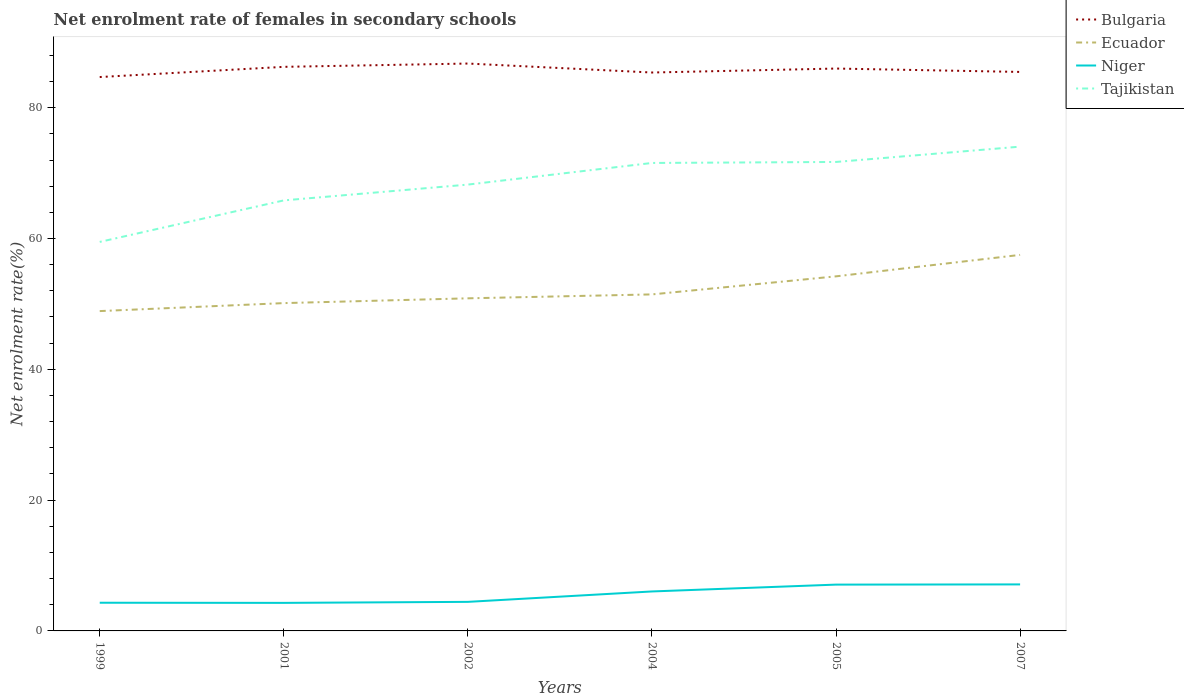How many different coloured lines are there?
Your answer should be compact. 4. Does the line corresponding to Bulgaria intersect with the line corresponding to Ecuador?
Ensure brevity in your answer.  No. Across all years, what is the maximum net enrolment rate of females in secondary schools in Tajikistan?
Provide a short and direct response. 59.48. In which year was the net enrolment rate of females in secondary schools in Bulgaria maximum?
Your answer should be very brief. 1999. What is the total net enrolment rate of females in secondary schools in Tajikistan in the graph?
Your answer should be very brief. -8.22. What is the difference between the highest and the second highest net enrolment rate of females in secondary schools in Tajikistan?
Your answer should be very brief. 14.57. What is the difference between the highest and the lowest net enrolment rate of females in secondary schools in Bulgaria?
Your response must be concise. 3. How many lines are there?
Provide a succinct answer. 4. What is the difference between two consecutive major ticks on the Y-axis?
Your answer should be very brief. 20. Are the values on the major ticks of Y-axis written in scientific E-notation?
Your answer should be very brief. No. How many legend labels are there?
Offer a very short reply. 4. How are the legend labels stacked?
Keep it short and to the point. Vertical. What is the title of the graph?
Your answer should be very brief. Net enrolment rate of females in secondary schools. Does "Sub-Saharan Africa (all income levels)" appear as one of the legend labels in the graph?
Provide a short and direct response. No. What is the label or title of the Y-axis?
Provide a short and direct response. Net enrolment rate(%). What is the Net enrolment rate(%) of Bulgaria in 1999?
Keep it short and to the point. 84.69. What is the Net enrolment rate(%) in Ecuador in 1999?
Give a very brief answer. 48.9. What is the Net enrolment rate(%) in Niger in 1999?
Provide a succinct answer. 4.31. What is the Net enrolment rate(%) in Tajikistan in 1999?
Provide a succinct answer. 59.48. What is the Net enrolment rate(%) in Bulgaria in 2001?
Offer a terse response. 86.25. What is the Net enrolment rate(%) of Ecuador in 2001?
Keep it short and to the point. 50.12. What is the Net enrolment rate(%) of Niger in 2001?
Offer a terse response. 4.29. What is the Net enrolment rate(%) in Tajikistan in 2001?
Provide a succinct answer. 65.83. What is the Net enrolment rate(%) in Bulgaria in 2002?
Your answer should be very brief. 86.75. What is the Net enrolment rate(%) of Ecuador in 2002?
Provide a succinct answer. 50.85. What is the Net enrolment rate(%) in Niger in 2002?
Offer a very short reply. 4.44. What is the Net enrolment rate(%) in Tajikistan in 2002?
Keep it short and to the point. 68.24. What is the Net enrolment rate(%) of Bulgaria in 2004?
Offer a terse response. 85.38. What is the Net enrolment rate(%) of Ecuador in 2004?
Offer a terse response. 51.45. What is the Net enrolment rate(%) of Niger in 2004?
Ensure brevity in your answer.  6.04. What is the Net enrolment rate(%) in Tajikistan in 2004?
Provide a succinct answer. 71.55. What is the Net enrolment rate(%) in Bulgaria in 2005?
Offer a terse response. 85.99. What is the Net enrolment rate(%) of Ecuador in 2005?
Your answer should be very brief. 54.21. What is the Net enrolment rate(%) in Niger in 2005?
Provide a short and direct response. 7.08. What is the Net enrolment rate(%) in Tajikistan in 2005?
Offer a terse response. 71.7. What is the Net enrolment rate(%) of Bulgaria in 2007?
Provide a succinct answer. 85.47. What is the Net enrolment rate(%) of Ecuador in 2007?
Keep it short and to the point. 57.49. What is the Net enrolment rate(%) of Niger in 2007?
Keep it short and to the point. 7.11. What is the Net enrolment rate(%) of Tajikistan in 2007?
Your answer should be compact. 74.05. Across all years, what is the maximum Net enrolment rate(%) of Bulgaria?
Make the answer very short. 86.75. Across all years, what is the maximum Net enrolment rate(%) in Ecuador?
Give a very brief answer. 57.49. Across all years, what is the maximum Net enrolment rate(%) of Niger?
Ensure brevity in your answer.  7.11. Across all years, what is the maximum Net enrolment rate(%) of Tajikistan?
Your answer should be very brief. 74.05. Across all years, what is the minimum Net enrolment rate(%) of Bulgaria?
Make the answer very short. 84.69. Across all years, what is the minimum Net enrolment rate(%) of Ecuador?
Your answer should be compact. 48.9. Across all years, what is the minimum Net enrolment rate(%) of Niger?
Ensure brevity in your answer.  4.29. Across all years, what is the minimum Net enrolment rate(%) of Tajikistan?
Provide a succinct answer. 59.48. What is the total Net enrolment rate(%) in Bulgaria in the graph?
Ensure brevity in your answer.  514.52. What is the total Net enrolment rate(%) of Ecuador in the graph?
Give a very brief answer. 313.04. What is the total Net enrolment rate(%) in Niger in the graph?
Offer a very short reply. 33.27. What is the total Net enrolment rate(%) of Tajikistan in the graph?
Offer a very short reply. 410.85. What is the difference between the Net enrolment rate(%) of Bulgaria in 1999 and that in 2001?
Ensure brevity in your answer.  -1.56. What is the difference between the Net enrolment rate(%) in Ecuador in 1999 and that in 2001?
Keep it short and to the point. -1.22. What is the difference between the Net enrolment rate(%) of Niger in 1999 and that in 2001?
Your response must be concise. 0.02. What is the difference between the Net enrolment rate(%) in Tajikistan in 1999 and that in 2001?
Your response must be concise. -6.35. What is the difference between the Net enrolment rate(%) in Bulgaria in 1999 and that in 2002?
Provide a succinct answer. -2.06. What is the difference between the Net enrolment rate(%) in Ecuador in 1999 and that in 2002?
Your answer should be very brief. -1.95. What is the difference between the Net enrolment rate(%) of Niger in 1999 and that in 2002?
Your response must be concise. -0.13. What is the difference between the Net enrolment rate(%) of Tajikistan in 1999 and that in 2002?
Offer a terse response. -8.77. What is the difference between the Net enrolment rate(%) of Bulgaria in 1999 and that in 2004?
Your answer should be compact. -0.69. What is the difference between the Net enrolment rate(%) of Ecuador in 1999 and that in 2004?
Your response must be concise. -2.55. What is the difference between the Net enrolment rate(%) of Niger in 1999 and that in 2004?
Offer a terse response. -1.73. What is the difference between the Net enrolment rate(%) of Tajikistan in 1999 and that in 2004?
Give a very brief answer. -12.07. What is the difference between the Net enrolment rate(%) of Bulgaria in 1999 and that in 2005?
Ensure brevity in your answer.  -1.3. What is the difference between the Net enrolment rate(%) in Ecuador in 1999 and that in 2005?
Your answer should be compact. -5.31. What is the difference between the Net enrolment rate(%) in Niger in 1999 and that in 2005?
Give a very brief answer. -2.77. What is the difference between the Net enrolment rate(%) of Tajikistan in 1999 and that in 2005?
Make the answer very short. -12.23. What is the difference between the Net enrolment rate(%) of Bulgaria in 1999 and that in 2007?
Provide a succinct answer. -0.78. What is the difference between the Net enrolment rate(%) in Ecuador in 1999 and that in 2007?
Provide a succinct answer. -8.59. What is the difference between the Net enrolment rate(%) of Niger in 1999 and that in 2007?
Make the answer very short. -2.8. What is the difference between the Net enrolment rate(%) of Tajikistan in 1999 and that in 2007?
Provide a succinct answer. -14.57. What is the difference between the Net enrolment rate(%) of Bulgaria in 2001 and that in 2002?
Your answer should be very brief. -0.51. What is the difference between the Net enrolment rate(%) of Ecuador in 2001 and that in 2002?
Keep it short and to the point. -0.73. What is the difference between the Net enrolment rate(%) of Niger in 2001 and that in 2002?
Offer a terse response. -0.16. What is the difference between the Net enrolment rate(%) in Tajikistan in 2001 and that in 2002?
Offer a terse response. -2.42. What is the difference between the Net enrolment rate(%) in Bulgaria in 2001 and that in 2004?
Offer a very short reply. 0.87. What is the difference between the Net enrolment rate(%) in Ecuador in 2001 and that in 2004?
Offer a very short reply. -1.33. What is the difference between the Net enrolment rate(%) in Niger in 2001 and that in 2004?
Give a very brief answer. -1.75. What is the difference between the Net enrolment rate(%) of Tajikistan in 2001 and that in 2004?
Make the answer very short. -5.72. What is the difference between the Net enrolment rate(%) in Bulgaria in 2001 and that in 2005?
Keep it short and to the point. 0.26. What is the difference between the Net enrolment rate(%) of Ecuador in 2001 and that in 2005?
Offer a terse response. -4.09. What is the difference between the Net enrolment rate(%) in Niger in 2001 and that in 2005?
Offer a very short reply. -2.79. What is the difference between the Net enrolment rate(%) of Tajikistan in 2001 and that in 2005?
Make the answer very short. -5.88. What is the difference between the Net enrolment rate(%) in Bulgaria in 2001 and that in 2007?
Offer a terse response. 0.78. What is the difference between the Net enrolment rate(%) in Ecuador in 2001 and that in 2007?
Provide a short and direct response. -7.37. What is the difference between the Net enrolment rate(%) of Niger in 2001 and that in 2007?
Keep it short and to the point. -2.82. What is the difference between the Net enrolment rate(%) in Tajikistan in 2001 and that in 2007?
Offer a very short reply. -8.22. What is the difference between the Net enrolment rate(%) of Bulgaria in 2002 and that in 2004?
Ensure brevity in your answer.  1.37. What is the difference between the Net enrolment rate(%) in Ecuador in 2002 and that in 2004?
Your response must be concise. -0.6. What is the difference between the Net enrolment rate(%) in Niger in 2002 and that in 2004?
Provide a short and direct response. -1.59. What is the difference between the Net enrolment rate(%) of Tajikistan in 2002 and that in 2004?
Offer a terse response. -3.31. What is the difference between the Net enrolment rate(%) of Bulgaria in 2002 and that in 2005?
Your response must be concise. 0.77. What is the difference between the Net enrolment rate(%) in Ecuador in 2002 and that in 2005?
Ensure brevity in your answer.  -3.36. What is the difference between the Net enrolment rate(%) in Niger in 2002 and that in 2005?
Provide a succinct answer. -2.64. What is the difference between the Net enrolment rate(%) in Tajikistan in 2002 and that in 2005?
Ensure brevity in your answer.  -3.46. What is the difference between the Net enrolment rate(%) of Bulgaria in 2002 and that in 2007?
Ensure brevity in your answer.  1.28. What is the difference between the Net enrolment rate(%) in Ecuador in 2002 and that in 2007?
Give a very brief answer. -6.64. What is the difference between the Net enrolment rate(%) in Niger in 2002 and that in 2007?
Keep it short and to the point. -2.67. What is the difference between the Net enrolment rate(%) of Tajikistan in 2002 and that in 2007?
Provide a succinct answer. -5.8. What is the difference between the Net enrolment rate(%) in Bulgaria in 2004 and that in 2005?
Provide a succinct answer. -0.61. What is the difference between the Net enrolment rate(%) in Ecuador in 2004 and that in 2005?
Your answer should be very brief. -2.76. What is the difference between the Net enrolment rate(%) in Niger in 2004 and that in 2005?
Make the answer very short. -1.05. What is the difference between the Net enrolment rate(%) of Tajikistan in 2004 and that in 2005?
Your answer should be compact. -0.15. What is the difference between the Net enrolment rate(%) of Bulgaria in 2004 and that in 2007?
Offer a terse response. -0.09. What is the difference between the Net enrolment rate(%) of Ecuador in 2004 and that in 2007?
Your answer should be very brief. -6.04. What is the difference between the Net enrolment rate(%) of Niger in 2004 and that in 2007?
Give a very brief answer. -1.08. What is the difference between the Net enrolment rate(%) of Tajikistan in 2004 and that in 2007?
Your answer should be very brief. -2.5. What is the difference between the Net enrolment rate(%) of Bulgaria in 2005 and that in 2007?
Your answer should be very brief. 0.52. What is the difference between the Net enrolment rate(%) in Ecuador in 2005 and that in 2007?
Provide a short and direct response. -3.28. What is the difference between the Net enrolment rate(%) of Niger in 2005 and that in 2007?
Provide a short and direct response. -0.03. What is the difference between the Net enrolment rate(%) in Tajikistan in 2005 and that in 2007?
Keep it short and to the point. -2.34. What is the difference between the Net enrolment rate(%) in Bulgaria in 1999 and the Net enrolment rate(%) in Ecuador in 2001?
Offer a terse response. 34.56. What is the difference between the Net enrolment rate(%) of Bulgaria in 1999 and the Net enrolment rate(%) of Niger in 2001?
Give a very brief answer. 80.4. What is the difference between the Net enrolment rate(%) of Bulgaria in 1999 and the Net enrolment rate(%) of Tajikistan in 2001?
Ensure brevity in your answer.  18.86. What is the difference between the Net enrolment rate(%) in Ecuador in 1999 and the Net enrolment rate(%) in Niger in 2001?
Make the answer very short. 44.61. What is the difference between the Net enrolment rate(%) of Ecuador in 1999 and the Net enrolment rate(%) of Tajikistan in 2001?
Give a very brief answer. -16.92. What is the difference between the Net enrolment rate(%) of Niger in 1999 and the Net enrolment rate(%) of Tajikistan in 2001?
Provide a short and direct response. -61.52. What is the difference between the Net enrolment rate(%) of Bulgaria in 1999 and the Net enrolment rate(%) of Ecuador in 2002?
Provide a succinct answer. 33.83. What is the difference between the Net enrolment rate(%) in Bulgaria in 1999 and the Net enrolment rate(%) in Niger in 2002?
Make the answer very short. 80.24. What is the difference between the Net enrolment rate(%) in Bulgaria in 1999 and the Net enrolment rate(%) in Tajikistan in 2002?
Provide a succinct answer. 16.44. What is the difference between the Net enrolment rate(%) in Ecuador in 1999 and the Net enrolment rate(%) in Niger in 2002?
Offer a very short reply. 44.46. What is the difference between the Net enrolment rate(%) in Ecuador in 1999 and the Net enrolment rate(%) in Tajikistan in 2002?
Offer a terse response. -19.34. What is the difference between the Net enrolment rate(%) in Niger in 1999 and the Net enrolment rate(%) in Tajikistan in 2002?
Make the answer very short. -63.93. What is the difference between the Net enrolment rate(%) of Bulgaria in 1999 and the Net enrolment rate(%) of Ecuador in 2004?
Your response must be concise. 33.23. What is the difference between the Net enrolment rate(%) in Bulgaria in 1999 and the Net enrolment rate(%) in Niger in 2004?
Offer a terse response. 78.65. What is the difference between the Net enrolment rate(%) in Bulgaria in 1999 and the Net enrolment rate(%) in Tajikistan in 2004?
Keep it short and to the point. 13.14. What is the difference between the Net enrolment rate(%) in Ecuador in 1999 and the Net enrolment rate(%) in Niger in 2004?
Make the answer very short. 42.87. What is the difference between the Net enrolment rate(%) of Ecuador in 1999 and the Net enrolment rate(%) of Tajikistan in 2004?
Provide a short and direct response. -22.65. What is the difference between the Net enrolment rate(%) of Niger in 1999 and the Net enrolment rate(%) of Tajikistan in 2004?
Your answer should be compact. -67.24. What is the difference between the Net enrolment rate(%) of Bulgaria in 1999 and the Net enrolment rate(%) of Ecuador in 2005?
Make the answer very short. 30.47. What is the difference between the Net enrolment rate(%) in Bulgaria in 1999 and the Net enrolment rate(%) in Niger in 2005?
Give a very brief answer. 77.61. What is the difference between the Net enrolment rate(%) in Bulgaria in 1999 and the Net enrolment rate(%) in Tajikistan in 2005?
Offer a very short reply. 12.98. What is the difference between the Net enrolment rate(%) of Ecuador in 1999 and the Net enrolment rate(%) of Niger in 2005?
Your response must be concise. 41.82. What is the difference between the Net enrolment rate(%) in Ecuador in 1999 and the Net enrolment rate(%) in Tajikistan in 2005?
Your response must be concise. -22.8. What is the difference between the Net enrolment rate(%) of Niger in 1999 and the Net enrolment rate(%) of Tajikistan in 2005?
Give a very brief answer. -67.39. What is the difference between the Net enrolment rate(%) in Bulgaria in 1999 and the Net enrolment rate(%) in Ecuador in 2007?
Your response must be concise. 27.19. What is the difference between the Net enrolment rate(%) of Bulgaria in 1999 and the Net enrolment rate(%) of Niger in 2007?
Your answer should be very brief. 77.58. What is the difference between the Net enrolment rate(%) of Bulgaria in 1999 and the Net enrolment rate(%) of Tajikistan in 2007?
Your answer should be very brief. 10.64. What is the difference between the Net enrolment rate(%) of Ecuador in 1999 and the Net enrolment rate(%) of Niger in 2007?
Make the answer very short. 41.79. What is the difference between the Net enrolment rate(%) in Ecuador in 1999 and the Net enrolment rate(%) in Tajikistan in 2007?
Your answer should be compact. -25.14. What is the difference between the Net enrolment rate(%) in Niger in 1999 and the Net enrolment rate(%) in Tajikistan in 2007?
Offer a terse response. -69.73. What is the difference between the Net enrolment rate(%) of Bulgaria in 2001 and the Net enrolment rate(%) of Ecuador in 2002?
Keep it short and to the point. 35.39. What is the difference between the Net enrolment rate(%) of Bulgaria in 2001 and the Net enrolment rate(%) of Niger in 2002?
Ensure brevity in your answer.  81.8. What is the difference between the Net enrolment rate(%) of Bulgaria in 2001 and the Net enrolment rate(%) of Tajikistan in 2002?
Provide a succinct answer. 18. What is the difference between the Net enrolment rate(%) in Ecuador in 2001 and the Net enrolment rate(%) in Niger in 2002?
Your answer should be compact. 45.68. What is the difference between the Net enrolment rate(%) in Ecuador in 2001 and the Net enrolment rate(%) in Tajikistan in 2002?
Provide a succinct answer. -18.12. What is the difference between the Net enrolment rate(%) in Niger in 2001 and the Net enrolment rate(%) in Tajikistan in 2002?
Give a very brief answer. -63.95. What is the difference between the Net enrolment rate(%) in Bulgaria in 2001 and the Net enrolment rate(%) in Ecuador in 2004?
Ensure brevity in your answer.  34.79. What is the difference between the Net enrolment rate(%) of Bulgaria in 2001 and the Net enrolment rate(%) of Niger in 2004?
Provide a short and direct response. 80.21. What is the difference between the Net enrolment rate(%) in Bulgaria in 2001 and the Net enrolment rate(%) in Tajikistan in 2004?
Make the answer very short. 14.7. What is the difference between the Net enrolment rate(%) in Ecuador in 2001 and the Net enrolment rate(%) in Niger in 2004?
Offer a terse response. 44.09. What is the difference between the Net enrolment rate(%) of Ecuador in 2001 and the Net enrolment rate(%) of Tajikistan in 2004?
Keep it short and to the point. -21.43. What is the difference between the Net enrolment rate(%) in Niger in 2001 and the Net enrolment rate(%) in Tajikistan in 2004?
Provide a short and direct response. -67.26. What is the difference between the Net enrolment rate(%) of Bulgaria in 2001 and the Net enrolment rate(%) of Ecuador in 2005?
Your response must be concise. 32.03. What is the difference between the Net enrolment rate(%) of Bulgaria in 2001 and the Net enrolment rate(%) of Niger in 2005?
Ensure brevity in your answer.  79.17. What is the difference between the Net enrolment rate(%) of Bulgaria in 2001 and the Net enrolment rate(%) of Tajikistan in 2005?
Your answer should be compact. 14.54. What is the difference between the Net enrolment rate(%) in Ecuador in 2001 and the Net enrolment rate(%) in Niger in 2005?
Your answer should be compact. 43.04. What is the difference between the Net enrolment rate(%) in Ecuador in 2001 and the Net enrolment rate(%) in Tajikistan in 2005?
Provide a short and direct response. -21.58. What is the difference between the Net enrolment rate(%) of Niger in 2001 and the Net enrolment rate(%) of Tajikistan in 2005?
Ensure brevity in your answer.  -67.42. What is the difference between the Net enrolment rate(%) in Bulgaria in 2001 and the Net enrolment rate(%) in Ecuador in 2007?
Your answer should be very brief. 28.75. What is the difference between the Net enrolment rate(%) in Bulgaria in 2001 and the Net enrolment rate(%) in Niger in 2007?
Your answer should be compact. 79.13. What is the difference between the Net enrolment rate(%) in Bulgaria in 2001 and the Net enrolment rate(%) in Tajikistan in 2007?
Provide a short and direct response. 12.2. What is the difference between the Net enrolment rate(%) in Ecuador in 2001 and the Net enrolment rate(%) in Niger in 2007?
Give a very brief answer. 43.01. What is the difference between the Net enrolment rate(%) of Ecuador in 2001 and the Net enrolment rate(%) of Tajikistan in 2007?
Offer a terse response. -23.92. What is the difference between the Net enrolment rate(%) of Niger in 2001 and the Net enrolment rate(%) of Tajikistan in 2007?
Keep it short and to the point. -69.76. What is the difference between the Net enrolment rate(%) in Bulgaria in 2002 and the Net enrolment rate(%) in Ecuador in 2004?
Offer a terse response. 35.3. What is the difference between the Net enrolment rate(%) of Bulgaria in 2002 and the Net enrolment rate(%) of Niger in 2004?
Offer a very short reply. 80.72. What is the difference between the Net enrolment rate(%) in Bulgaria in 2002 and the Net enrolment rate(%) in Tajikistan in 2004?
Your response must be concise. 15.2. What is the difference between the Net enrolment rate(%) in Ecuador in 2002 and the Net enrolment rate(%) in Niger in 2004?
Offer a terse response. 44.82. What is the difference between the Net enrolment rate(%) in Ecuador in 2002 and the Net enrolment rate(%) in Tajikistan in 2004?
Keep it short and to the point. -20.7. What is the difference between the Net enrolment rate(%) of Niger in 2002 and the Net enrolment rate(%) of Tajikistan in 2004?
Provide a succinct answer. -67.11. What is the difference between the Net enrolment rate(%) in Bulgaria in 2002 and the Net enrolment rate(%) in Ecuador in 2005?
Offer a terse response. 32.54. What is the difference between the Net enrolment rate(%) of Bulgaria in 2002 and the Net enrolment rate(%) of Niger in 2005?
Ensure brevity in your answer.  79.67. What is the difference between the Net enrolment rate(%) of Bulgaria in 2002 and the Net enrolment rate(%) of Tajikistan in 2005?
Your answer should be compact. 15.05. What is the difference between the Net enrolment rate(%) in Ecuador in 2002 and the Net enrolment rate(%) in Niger in 2005?
Ensure brevity in your answer.  43.77. What is the difference between the Net enrolment rate(%) of Ecuador in 2002 and the Net enrolment rate(%) of Tajikistan in 2005?
Keep it short and to the point. -20.85. What is the difference between the Net enrolment rate(%) in Niger in 2002 and the Net enrolment rate(%) in Tajikistan in 2005?
Offer a very short reply. -67.26. What is the difference between the Net enrolment rate(%) of Bulgaria in 2002 and the Net enrolment rate(%) of Ecuador in 2007?
Ensure brevity in your answer.  29.26. What is the difference between the Net enrolment rate(%) in Bulgaria in 2002 and the Net enrolment rate(%) in Niger in 2007?
Give a very brief answer. 79.64. What is the difference between the Net enrolment rate(%) of Bulgaria in 2002 and the Net enrolment rate(%) of Tajikistan in 2007?
Provide a succinct answer. 12.71. What is the difference between the Net enrolment rate(%) in Ecuador in 2002 and the Net enrolment rate(%) in Niger in 2007?
Provide a short and direct response. 43.74. What is the difference between the Net enrolment rate(%) in Ecuador in 2002 and the Net enrolment rate(%) in Tajikistan in 2007?
Offer a terse response. -23.19. What is the difference between the Net enrolment rate(%) in Niger in 2002 and the Net enrolment rate(%) in Tajikistan in 2007?
Provide a short and direct response. -69.6. What is the difference between the Net enrolment rate(%) of Bulgaria in 2004 and the Net enrolment rate(%) of Ecuador in 2005?
Provide a succinct answer. 31.16. What is the difference between the Net enrolment rate(%) in Bulgaria in 2004 and the Net enrolment rate(%) in Niger in 2005?
Your answer should be compact. 78.3. What is the difference between the Net enrolment rate(%) of Bulgaria in 2004 and the Net enrolment rate(%) of Tajikistan in 2005?
Your answer should be very brief. 13.67. What is the difference between the Net enrolment rate(%) in Ecuador in 2004 and the Net enrolment rate(%) in Niger in 2005?
Offer a terse response. 44.37. What is the difference between the Net enrolment rate(%) in Ecuador in 2004 and the Net enrolment rate(%) in Tajikistan in 2005?
Your response must be concise. -20.25. What is the difference between the Net enrolment rate(%) in Niger in 2004 and the Net enrolment rate(%) in Tajikistan in 2005?
Give a very brief answer. -65.67. What is the difference between the Net enrolment rate(%) of Bulgaria in 2004 and the Net enrolment rate(%) of Ecuador in 2007?
Keep it short and to the point. 27.89. What is the difference between the Net enrolment rate(%) in Bulgaria in 2004 and the Net enrolment rate(%) in Niger in 2007?
Ensure brevity in your answer.  78.27. What is the difference between the Net enrolment rate(%) in Bulgaria in 2004 and the Net enrolment rate(%) in Tajikistan in 2007?
Give a very brief answer. 11.33. What is the difference between the Net enrolment rate(%) of Ecuador in 2004 and the Net enrolment rate(%) of Niger in 2007?
Your answer should be very brief. 44.34. What is the difference between the Net enrolment rate(%) of Ecuador in 2004 and the Net enrolment rate(%) of Tajikistan in 2007?
Your response must be concise. -22.59. What is the difference between the Net enrolment rate(%) in Niger in 2004 and the Net enrolment rate(%) in Tajikistan in 2007?
Your response must be concise. -68.01. What is the difference between the Net enrolment rate(%) in Bulgaria in 2005 and the Net enrolment rate(%) in Ecuador in 2007?
Provide a succinct answer. 28.49. What is the difference between the Net enrolment rate(%) of Bulgaria in 2005 and the Net enrolment rate(%) of Niger in 2007?
Give a very brief answer. 78.88. What is the difference between the Net enrolment rate(%) of Bulgaria in 2005 and the Net enrolment rate(%) of Tajikistan in 2007?
Your answer should be compact. 11.94. What is the difference between the Net enrolment rate(%) in Ecuador in 2005 and the Net enrolment rate(%) in Niger in 2007?
Your answer should be very brief. 47.1. What is the difference between the Net enrolment rate(%) of Ecuador in 2005 and the Net enrolment rate(%) of Tajikistan in 2007?
Give a very brief answer. -19.83. What is the difference between the Net enrolment rate(%) of Niger in 2005 and the Net enrolment rate(%) of Tajikistan in 2007?
Keep it short and to the point. -66.96. What is the average Net enrolment rate(%) of Bulgaria per year?
Offer a terse response. 85.75. What is the average Net enrolment rate(%) in Ecuador per year?
Your answer should be compact. 52.17. What is the average Net enrolment rate(%) of Niger per year?
Your response must be concise. 5.55. What is the average Net enrolment rate(%) in Tajikistan per year?
Give a very brief answer. 68.47. In the year 1999, what is the difference between the Net enrolment rate(%) in Bulgaria and Net enrolment rate(%) in Ecuador?
Provide a succinct answer. 35.78. In the year 1999, what is the difference between the Net enrolment rate(%) in Bulgaria and Net enrolment rate(%) in Niger?
Keep it short and to the point. 80.38. In the year 1999, what is the difference between the Net enrolment rate(%) of Bulgaria and Net enrolment rate(%) of Tajikistan?
Offer a terse response. 25.21. In the year 1999, what is the difference between the Net enrolment rate(%) of Ecuador and Net enrolment rate(%) of Niger?
Give a very brief answer. 44.59. In the year 1999, what is the difference between the Net enrolment rate(%) of Ecuador and Net enrolment rate(%) of Tajikistan?
Keep it short and to the point. -10.58. In the year 1999, what is the difference between the Net enrolment rate(%) of Niger and Net enrolment rate(%) of Tajikistan?
Offer a terse response. -55.17. In the year 2001, what is the difference between the Net enrolment rate(%) of Bulgaria and Net enrolment rate(%) of Ecuador?
Offer a very short reply. 36.12. In the year 2001, what is the difference between the Net enrolment rate(%) in Bulgaria and Net enrolment rate(%) in Niger?
Provide a succinct answer. 81.96. In the year 2001, what is the difference between the Net enrolment rate(%) in Bulgaria and Net enrolment rate(%) in Tajikistan?
Offer a very short reply. 20.42. In the year 2001, what is the difference between the Net enrolment rate(%) of Ecuador and Net enrolment rate(%) of Niger?
Make the answer very short. 45.83. In the year 2001, what is the difference between the Net enrolment rate(%) in Ecuador and Net enrolment rate(%) in Tajikistan?
Give a very brief answer. -15.7. In the year 2001, what is the difference between the Net enrolment rate(%) in Niger and Net enrolment rate(%) in Tajikistan?
Keep it short and to the point. -61.54. In the year 2002, what is the difference between the Net enrolment rate(%) of Bulgaria and Net enrolment rate(%) of Ecuador?
Offer a very short reply. 35.9. In the year 2002, what is the difference between the Net enrolment rate(%) of Bulgaria and Net enrolment rate(%) of Niger?
Ensure brevity in your answer.  82.31. In the year 2002, what is the difference between the Net enrolment rate(%) in Bulgaria and Net enrolment rate(%) in Tajikistan?
Make the answer very short. 18.51. In the year 2002, what is the difference between the Net enrolment rate(%) of Ecuador and Net enrolment rate(%) of Niger?
Your answer should be very brief. 46.41. In the year 2002, what is the difference between the Net enrolment rate(%) of Ecuador and Net enrolment rate(%) of Tajikistan?
Provide a succinct answer. -17.39. In the year 2002, what is the difference between the Net enrolment rate(%) in Niger and Net enrolment rate(%) in Tajikistan?
Make the answer very short. -63.8. In the year 2004, what is the difference between the Net enrolment rate(%) in Bulgaria and Net enrolment rate(%) in Ecuador?
Ensure brevity in your answer.  33.93. In the year 2004, what is the difference between the Net enrolment rate(%) of Bulgaria and Net enrolment rate(%) of Niger?
Provide a short and direct response. 79.34. In the year 2004, what is the difference between the Net enrolment rate(%) of Bulgaria and Net enrolment rate(%) of Tajikistan?
Provide a succinct answer. 13.83. In the year 2004, what is the difference between the Net enrolment rate(%) of Ecuador and Net enrolment rate(%) of Niger?
Your answer should be very brief. 45.42. In the year 2004, what is the difference between the Net enrolment rate(%) in Ecuador and Net enrolment rate(%) in Tajikistan?
Keep it short and to the point. -20.1. In the year 2004, what is the difference between the Net enrolment rate(%) of Niger and Net enrolment rate(%) of Tajikistan?
Ensure brevity in your answer.  -65.51. In the year 2005, what is the difference between the Net enrolment rate(%) in Bulgaria and Net enrolment rate(%) in Ecuador?
Your response must be concise. 31.77. In the year 2005, what is the difference between the Net enrolment rate(%) in Bulgaria and Net enrolment rate(%) in Niger?
Give a very brief answer. 78.91. In the year 2005, what is the difference between the Net enrolment rate(%) of Bulgaria and Net enrolment rate(%) of Tajikistan?
Provide a short and direct response. 14.28. In the year 2005, what is the difference between the Net enrolment rate(%) of Ecuador and Net enrolment rate(%) of Niger?
Offer a very short reply. 47.13. In the year 2005, what is the difference between the Net enrolment rate(%) of Ecuador and Net enrolment rate(%) of Tajikistan?
Make the answer very short. -17.49. In the year 2005, what is the difference between the Net enrolment rate(%) in Niger and Net enrolment rate(%) in Tajikistan?
Keep it short and to the point. -64.62. In the year 2007, what is the difference between the Net enrolment rate(%) of Bulgaria and Net enrolment rate(%) of Ecuador?
Provide a succinct answer. 27.98. In the year 2007, what is the difference between the Net enrolment rate(%) in Bulgaria and Net enrolment rate(%) in Niger?
Offer a very short reply. 78.36. In the year 2007, what is the difference between the Net enrolment rate(%) of Bulgaria and Net enrolment rate(%) of Tajikistan?
Your answer should be very brief. 11.42. In the year 2007, what is the difference between the Net enrolment rate(%) in Ecuador and Net enrolment rate(%) in Niger?
Keep it short and to the point. 50.38. In the year 2007, what is the difference between the Net enrolment rate(%) in Ecuador and Net enrolment rate(%) in Tajikistan?
Offer a terse response. -16.55. In the year 2007, what is the difference between the Net enrolment rate(%) in Niger and Net enrolment rate(%) in Tajikistan?
Keep it short and to the point. -66.93. What is the ratio of the Net enrolment rate(%) of Bulgaria in 1999 to that in 2001?
Ensure brevity in your answer.  0.98. What is the ratio of the Net enrolment rate(%) of Ecuador in 1999 to that in 2001?
Offer a very short reply. 0.98. What is the ratio of the Net enrolment rate(%) of Tajikistan in 1999 to that in 2001?
Provide a succinct answer. 0.9. What is the ratio of the Net enrolment rate(%) of Bulgaria in 1999 to that in 2002?
Your answer should be very brief. 0.98. What is the ratio of the Net enrolment rate(%) in Ecuador in 1999 to that in 2002?
Your answer should be very brief. 0.96. What is the ratio of the Net enrolment rate(%) of Niger in 1999 to that in 2002?
Ensure brevity in your answer.  0.97. What is the ratio of the Net enrolment rate(%) in Tajikistan in 1999 to that in 2002?
Your answer should be compact. 0.87. What is the ratio of the Net enrolment rate(%) of Bulgaria in 1999 to that in 2004?
Keep it short and to the point. 0.99. What is the ratio of the Net enrolment rate(%) of Ecuador in 1999 to that in 2004?
Provide a succinct answer. 0.95. What is the ratio of the Net enrolment rate(%) in Niger in 1999 to that in 2004?
Your response must be concise. 0.71. What is the ratio of the Net enrolment rate(%) of Tajikistan in 1999 to that in 2004?
Give a very brief answer. 0.83. What is the ratio of the Net enrolment rate(%) in Bulgaria in 1999 to that in 2005?
Your answer should be compact. 0.98. What is the ratio of the Net enrolment rate(%) in Ecuador in 1999 to that in 2005?
Give a very brief answer. 0.9. What is the ratio of the Net enrolment rate(%) of Niger in 1999 to that in 2005?
Provide a succinct answer. 0.61. What is the ratio of the Net enrolment rate(%) in Tajikistan in 1999 to that in 2005?
Make the answer very short. 0.83. What is the ratio of the Net enrolment rate(%) in Bulgaria in 1999 to that in 2007?
Provide a succinct answer. 0.99. What is the ratio of the Net enrolment rate(%) of Ecuador in 1999 to that in 2007?
Make the answer very short. 0.85. What is the ratio of the Net enrolment rate(%) of Niger in 1999 to that in 2007?
Provide a short and direct response. 0.61. What is the ratio of the Net enrolment rate(%) in Tajikistan in 1999 to that in 2007?
Provide a short and direct response. 0.8. What is the ratio of the Net enrolment rate(%) of Bulgaria in 2001 to that in 2002?
Offer a very short reply. 0.99. What is the ratio of the Net enrolment rate(%) in Ecuador in 2001 to that in 2002?
Offer a terse response. 0.99. What is the ratio of the Net enrolment rate(%) of Niger in 2001 to that in 2002?
Offer a very short reply. 0.96. What is the ratio of the Net enrolment rate(%) in Tajikistan in 2001 to that in 2002?
Your response must be concise. 0.96. What is the ratio of the Net enrolment rate(%) of Bulgaria in 2001 to that in 2004?
Your response must be concise. 1.01. What is the ratio of the Net enrolment rate(%) of Ecuador in 2001 to that in 2004?
Make the answer very short. 0.97. What is the ratio of the Net enrolment rate(%) of Niger in 2001 to that in 2004?
Ensure brevity in your answer.  0.71. What is the ratio of the Net enrolment rate(%) of Bulgaria in 2001 to that in 2005?
Ensure brevity in your answer.  1. What is the ratio of the Net enrolment rate(%) of Ecuador in 2001 to that in 2005?
Give a very brief answer. 0.92. What is the ratio of the Net enrolment rate(%) in Niger in 2001 to that in 2005?
Offer a terse response. 0.61. What is the ratio of the Net enrolment rate(%) in Tajikistan in 2001 to that in 2005?
Make the answer very short. 0.92. What is the ratio of the Net enrolment rate(%) in Bulgaria in 2001 to that in 2007?
Make the answer very short. 1.01. What is the ratio of the Net enrolment rate(%) in Ecuador in 2001 to that in 2007?
Provide a succinct answer. 0.87. What is the ratio of the Net enrolment rate(%) in Niger in 2001 to that in 2007?
Your answer should be very brief. 0.6. What is the ratio of the Net enrolment rate(%) in Tajikistan in 2001 to that in 2007?
Offer a terse response. 0.89. What is the ratio of the Net enrolment rate(%) in Bulgaria in 2002 to that in 2004?
Offer a very short reply. 1.02. What is the ratio of the Net enrolment rate(%) in Ecuador in 2002 to that in 2004?
Make the answer very short. 0.99. What is the ratio of the Net enrolment rate(%) of Niger in 2002 to that in 2004?
Your answer should be compact. 0.74. What is the ratio of the Net enrolment rate(%) in Tajikistan in 2002 to that in 2004?
Provide a short and direct response. 0.95. What is the ratio of the Net enrolment rate(%) of Bulgaria in 2002 to that in 2005?
Give a very brief answer. 1.01. What is the ratio of the Net enrolment rate(%) of Ecuador in 2002 to that in 2005?
Provide a short and direct response. 0.94. What is the ratio of the Net enrolment rate(%) of Niger in 2002 to that in 2005?
Keep it short and to the point. 0.63. What is the ratio of the Net enrolment rate(%) in Tajikistan in 2002 to that in 2005?
Keep it short and to the point. 0.95. What is the ratio of the Net enrolment rate(%) of Ecuador in 2002 to that in 2007?
Your answer should be very brief. 0.88. What is the ratio of the Net enrolment rate(%) of Niger in 2002 to that in 2007?
Your answer should be very brief. 0.62. What is the ratio of the Net enrolment rate(%) of Tajikistan in 2002 to that in 2007?
Ensure brevity in your answer.  0.92. What is the ratio of the Net enrolment rate(%) of Ecuador in 2004 to that in 2005?
Give a very brief answer. 0.95. What is the ratio of the Net enrolment rate(%) in Niger in 2004 to that in 2005?
Keep it short and to the point. 0.85. What is the ratio of the Net enrolment rate(%) in Tajikistan in 2004 to that in 2005?
Provide a succinct answer. 1. What is the ratio of the Net enrolment rate(%) in Ecuador in 2004 to that in 2007?
Give a very brief answer. 0.89. What is the ratio of the Net enrolment rate(%) in Niger in 2004 to that in 2007?
Keep it short and to the point. 0.85. What is the ratio of the Net enrolment rate(%) of Tajikistan in 2004 to that in 2007?
Offer a very short reply. 0.97. What is the ratio of the Net enrolment rate(%) in Bulgaria in 2005 to that in 2007?
Provide a short and direct response. 1.01. What is the ratio of the Net enrolment rate(%) in Ecuador in 2005 to that in 2007?
Offer a terse response. 0.94. What is the ratio of the Net enrolment rate(%) in Tajikistan in 2005 to that in 2007?
Keep it short and to the point. 0.97. What is the difference between the highest and the second highest Net enrolment rate(%) in Bulgaria?
Offer a terse response. 0.51. What is the difference between the highest and the second highest Net enrolment rate(%) in Ecuador?
Your response must be concise. 3.28. What is the difference between the highest and the second highest Net enrolment rate(%) of Niger?
Your response must be concise. 0.03. What is the difference between the highest and the second highest Net enrolment rate(%) in Tajikistan?
Give a very brief answer. 2.34. What is the difference between the highest and the lowest Net enrolment rate(%) of Bulgaria?
Offer a terse response. 2.06. What is the difference between the highest and the lowest Net enrolment rate(%) in Ecuador?
Give a very brief answer. 8.59. What is the difference between the highest and the lowest Net enrolment rate(%) of Niger?
Your response must be concise. 2.82. What is the difference between the highest and the lowest Net enrolment rate(%) of Tajikistan?
Provide a short and direct response. 14.57. 